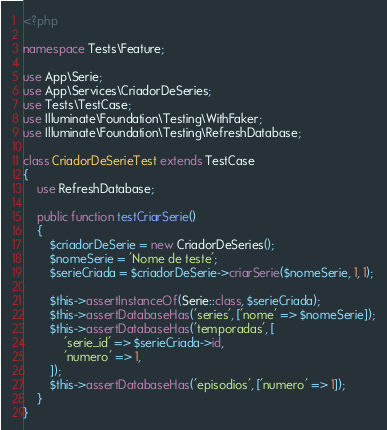<code> <loc_0><loc_0><loc_500><loc_500><_PHP_><?php

namespace Tests\Feature;

use App\Serie;
use App\Services\CriadorDeSeries;
use Tests\TestCase;
use Illuminate\Foundation\Testing\WithFaker;
use Illuminate\Foundation\Testing\RefreshDatabase;

class CriadorDeSerieTest extends TestCase
{
    use RefreshDatabase;

    public function testCriarSerie()
    {
        $criadorDeSerie = new CriadorDeSeries();
        $nomeSerie = 'Nome de teste';
        $serieCriada = $criadorDeSerie->criarSerie($nomeSerie, 1, 1);

        $this->assertInstanceOf(Serie::class, $serieCriada);
        $this->assertDatabaseHas('series', ['nome' => $nomeSerie]);
        $this->assertDatabaseHas('temporadas', [
            'serie_id' => $serieCriada->id,
            'numero' => 1,
        ]);
        $this->assertDatabaseHas('episodios', ['numero' => 1]);
    }
}
</code> 